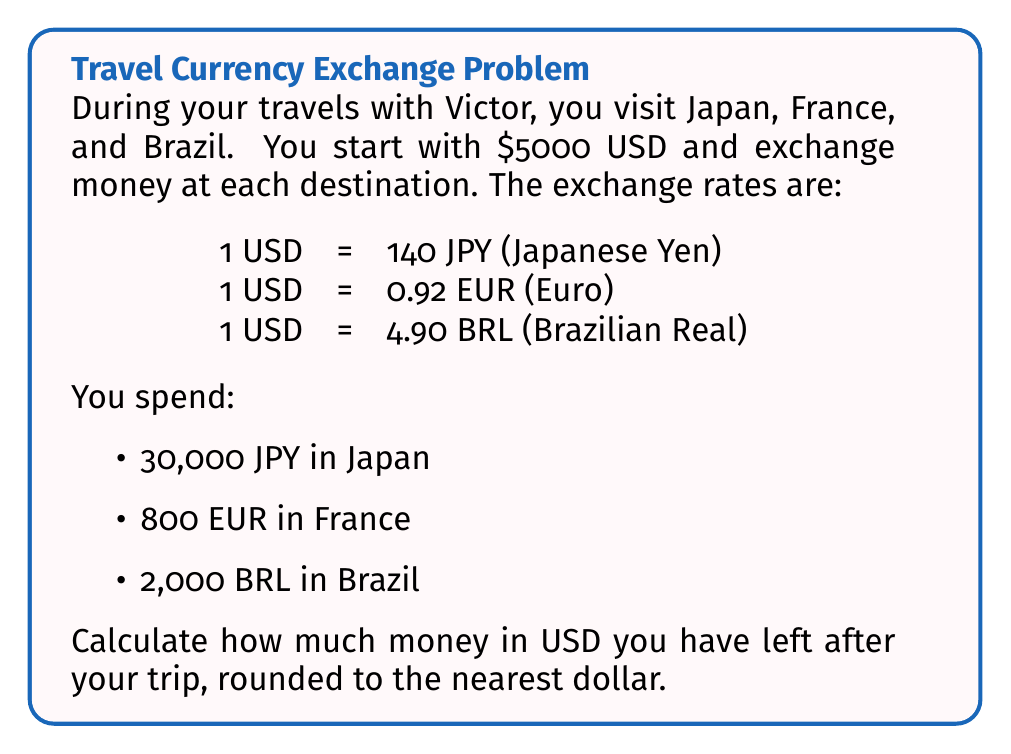Provide a solution to this math problem. Let's approach this step-by-step:

1) First, let's calculate how much USD was spent in each country:

   Japan: $\frac{30,000 \text{ JPY}}{140 \text{ JPY/USD}} = 214.29 \text{ USD}$

   France: $\frac{800 \text{ EUR}}{0.92 \text{ EUR/USD}} = 869.57 \text{ USD}$

   Brazil: $\frac{2,000 \text{ BRL}}{4.90 \text{ BRL/USD}} = 408.16 \text{ USD}$

2) Now, let's sum up the total USD spent:

   $\text{Total spent} = 214.29 + 869.57 + 408.16 = 1492.02 \text{ USD}$

3) Finally, we can subtract this from the initial amount:

   $\text{Remaining} = 5000 - 1492.02 = 3507.98 \text{ USD}$

4) Rounding to the nearest dollar:

   $3507.98 \approx 3508 \text{ USD}$
Answer: $3508 